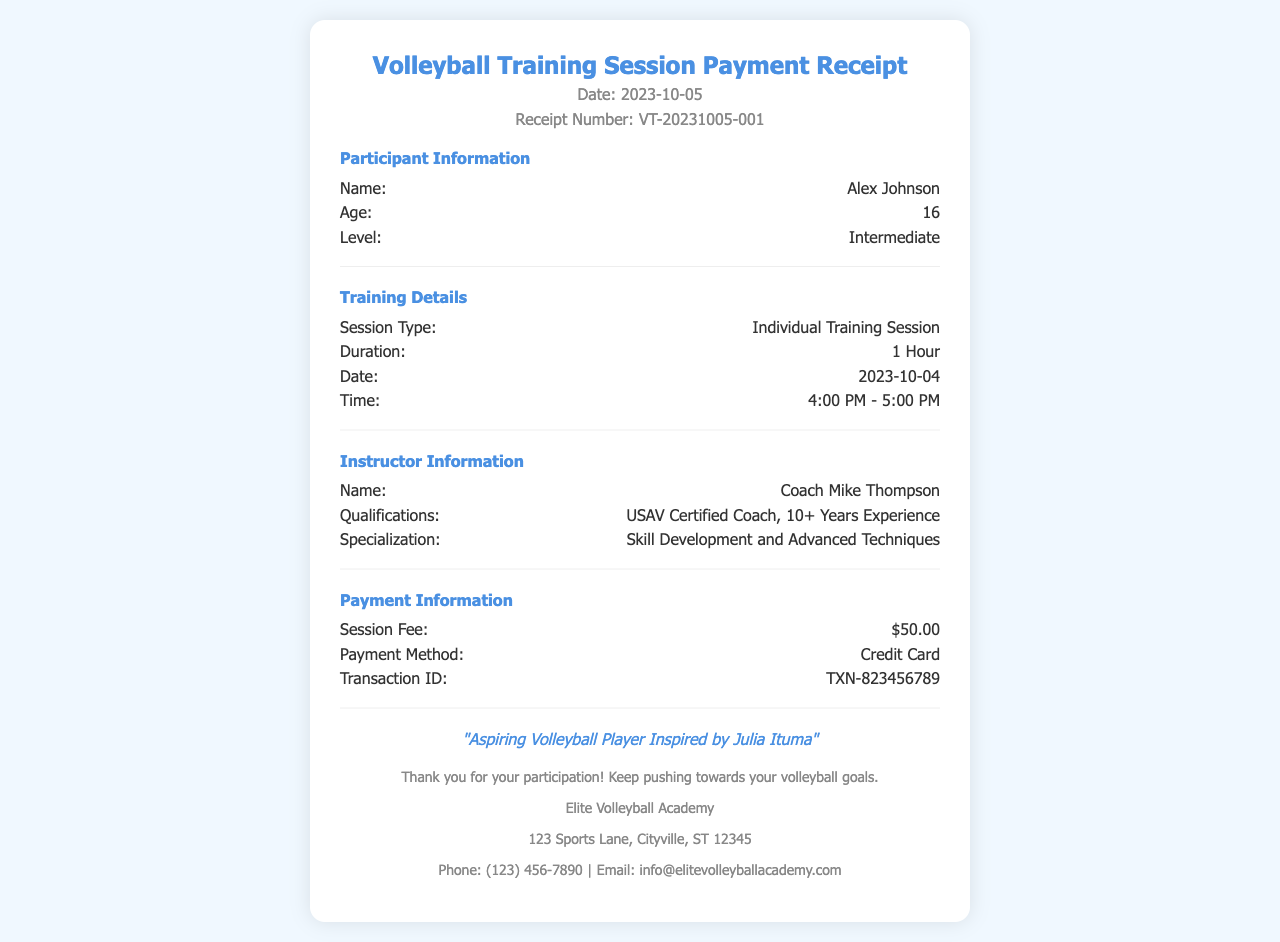What is the date of the receipt? The date of the receipt is specified in the header section of the document.
Answer: 2023-10-05 Who is the instructor for the training session? The name of the instructor is mentioned in the instructor information section.
Answer: Coach Mike Thompson What is the duration of the training session? The duration is clearly stated in the training details section of the document.
Answer: 1 Hour What is the session fee? The session fee is listed in the payment information section of the document.
Answer: $50.00 What qualifications does the instructor have? The qualifications of the instructor are included in the instructor information section.
Answer: USAV Certified Coach, 10+ Years Experience What time did the training session start? The start time is detailed in the training details section of the document.
Answer: 4:00 PM How did the participant pay for the session? The payment method is specified in the payment information section.
Answer: Credit Card What is the participant's age? The age of the participant is mentioned in the participant information section.
Answer: 16 What is the specialization of the instructor? The specialization is listed in the instructor information section of the document.
Answer: Skill Development and Advanced Techniques 